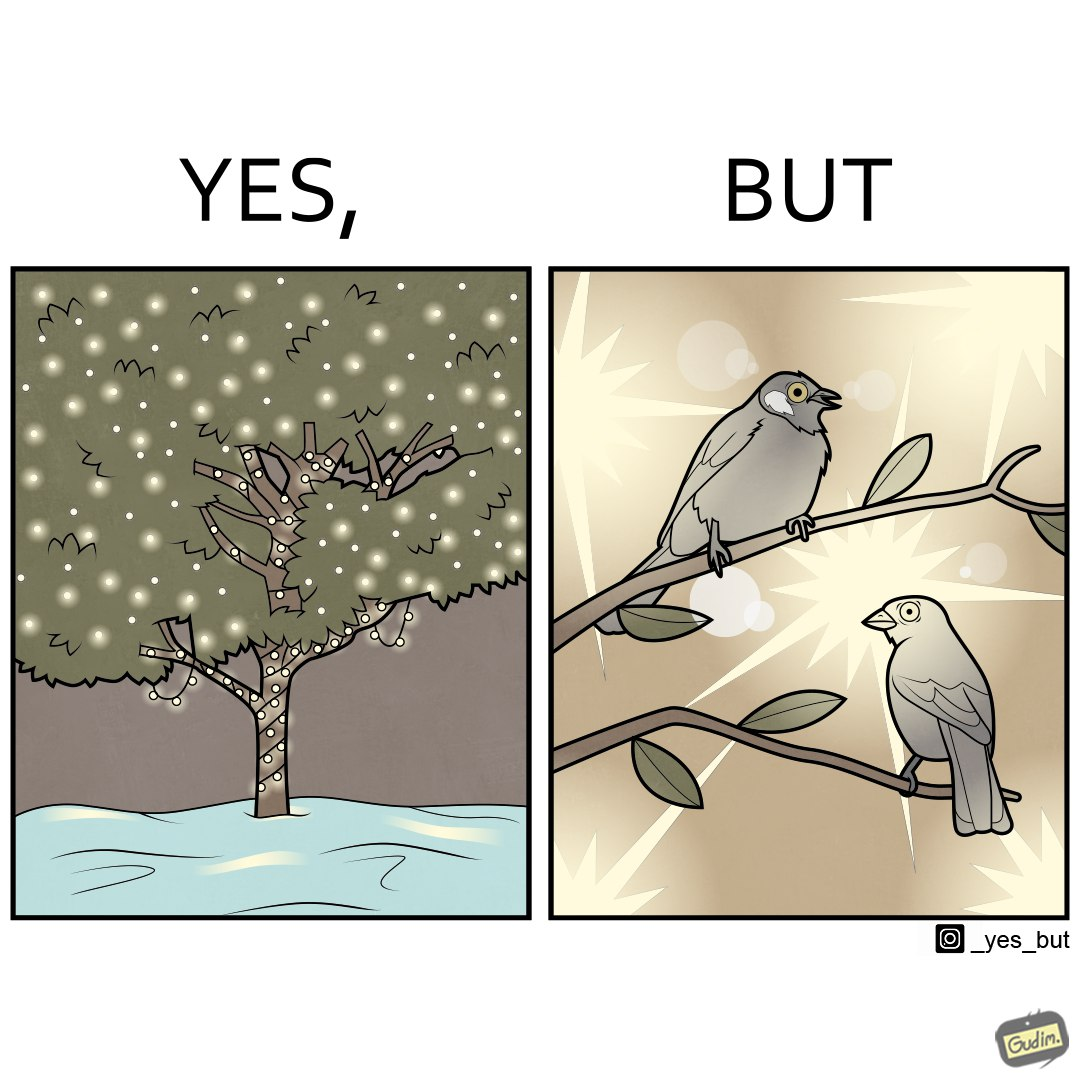What is shown in the left half versus the right half of this image? In the left part of the image: A tree decorated with lights all over it In the right part of the image: Birds dazzled by many lights 